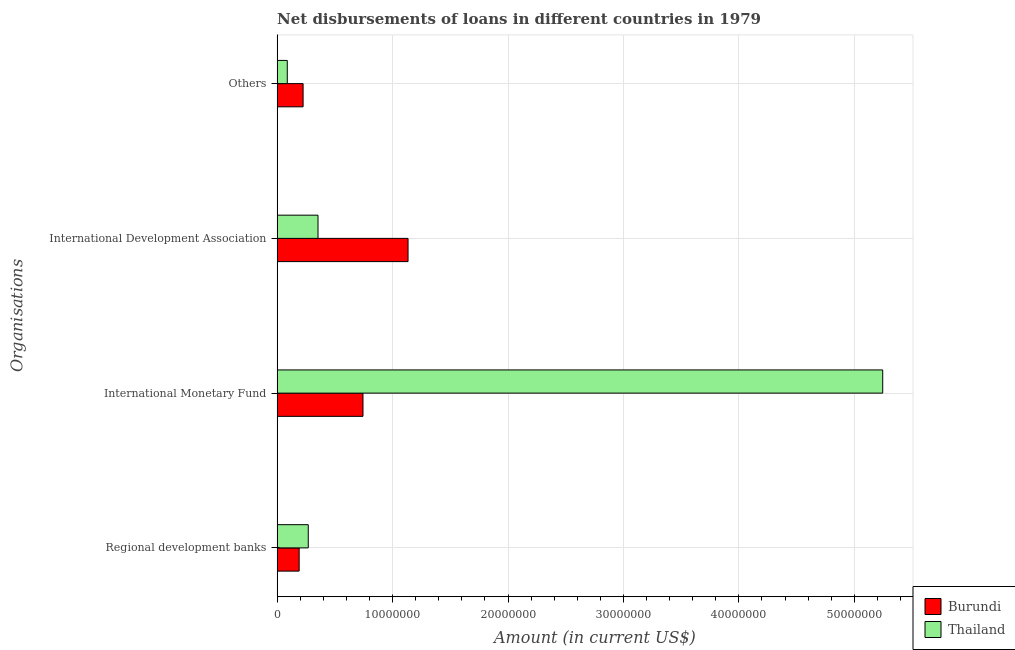How many different coloured bars are there?
Your answer should be very brief. 2. Are the number of bars per tick equal to the number of legend labels?
Offer a terse response. Yes. How many bars are there on the 4th tick from the top?
Ensure brevity in your answer.  2. How many bars are there on the 3rd tick from the bottom?
Keep it short and to the point. 2. What is the label of the 1st group of bars from the top?
Your answer should be compact. Others. What is the amount of loan disimbursed by international monetary fund in Burundi?
Your answer should be compact. 7.44e+06. Across all countries, what is the maximum amount of loan disimbursed by international development association?
Your response must be concise. 1.13e+07. Across all countries, what is the minimum amount of loan disimbursed by international monetary fund?
Make the answer very short. 7.44e+06. In which country was the amount of loan disimbursed by international monetary fund maximum?
Give a very brief answer. Thailand. In which country was the amount of loan disimbursed by international development association minimum?
Offer a terse response. Thailand. What is the total amount of loan disimbursed by international development association in the graph?
Provide a short and direct response. 1.49e+07. What is the difference between the amount of loan disimbursed by international development association in Burundi and that in Thailand?
Provide a succinct answer. 7.80e+06. What is the difference between the amount of loan disimbursed by international development association in Burundi and the amount of loan disimbursed by other organisations in Thailand?
Make the answer very short. 1.05e+07. What is the average amount of loan disimbursed by other organisations per country?
Keep it short and to the point. 1.56e+06. What is the difference between the amount of loan disimbursed by other organisations and amount of loan disimbursed by regional development banks in Burundi?
Provide a short and direct response. 3.42e+05. What is the ratio of the amount of loan disimbursed by international development association in Burundi to that in Thailand?
Provide a short and direct response. 3.2. Is the amount of loan disimbursed by international development association in Burundi less than that in Thailand?
Your answer should be very brief. No. What is the difference between the highest and the second highest amount of loan disimbursed by regional development banks?
Ensure brevity in your answer.  7.90e+05. What is the difference between the highest and the lowest amount of loan disimbursed by international development association?
Offer a terse response. 7.80e+06. In how many countries, is the amount of loan disimbursed by other organisations greater than the average amount of loan disimbursed by other organisations taken over all countries?
Provide a succinct answer. 1. Is the sum of the amount of loan disimbursed by international development association in Burundi and Thailand greater than the maximum amount of loan disimbursed by regional development banks across all countries?
Offer a very short reply. Yes. What does the 1st bar from the top in International Monetary Fund represents?
Ensure brevity in your answer.  Thailand. What does the 1st bar from the bottom in International Development Association represents?
Your response must be concise. Burundi. Are all the bars in the graph horizontal?
Your answer should be compact. Yes. What is the difference between two consecutive major ticks on the X-axis?
Offer a terse response. 1.00e+07. Are the values on the major ticks of X-axis written in scientific E-notation?
Provide a short and direct response. No. Does the graph contain any zero values?
Your answer should be very brief. No. Does the graph contain grids?
Provide a short and direct response. Yes. What is the title of the graph?
Offer a terse response. Net disbursements of loans in different countries in 1979. What is the label or title of the Y-axis?
Provide a short and direct response. Organisations. What is the Amount (in current US$) of Burundi in Regional development banks?
Your answer should be very brief. 1.91e+06. What is the Amount (in current US$) in Thailand in Regional development banks?
Your answer should be compact. 2.70e+06. What is the Amount (in current US$) in Burundi in International Monetary Fund?
Your response must be concise. 7.44e+06. What is the Amount (in current US$) of Thailand in International Monetary Fund?
Ensure brevity in your answer.  5.25e+07. What is the Amount (in current US$) of Burundi in International Development Association?
Provide a short and direct response. 1.13e+07. What is the Amount (in current US$) of Thailand in International Development Association?
Your response must be concise. 3.54e+06. What is the Amount (in current US$) in Burundi in Others?
Your answer should be compact. 2.25e+06. What is the Amount (in current US$) in Thailand in Others?
Offer a very short reply. 8.80e+05. Across all Organisations, what is the maximum Amount (in current US$) of Burundi?
Keep it short and to the point. 1.13e+07. Across all Organisations, what is the maximum Amount (in current US$) in Thailand?
Offer a very short reply. 5.25e+07. Across all Organisations, what is the minimum Amount (in current US$) in Burundi?
Provide a succinct answer. 1.91e+06. Across all Organisations, what is the minimum Amount (in current US$) in Thailand?
Your answer should be very brief. 8.80e+05. What is the total Amount (in current US$) in Burundi in the graph?
Provide a succinct answer. 2.29e+07. What is the total Amount (in current US$) of Thailand in the graph?
Offer a terse response. 5.96e+07. What is the difference between the Amount (in current US$) in Burundi in Regional development banks and that in International Monetary Fund?
Offer a very short reply. -5.53e+06. What is the difference between the Amount (in current US$) of Thailand in Regional development banks and that in International Monetary Fund?
Ensure brevity in your answer.  -4.98e+07. What is the difference between the Amount (in current US$) in Burundi in Regional development banks and that in International Development Association?
Give a very brief answer. -9.43e+06. What is the difference between the Amount (in current US$) of Thailand in Regional development banks and that in International Development Association?
Keep it short and to the point. -8.44e+05. What is the difference between the Amount (in current US$) in Burundi in Regional development banks and that in Others?
Your answer should be very brief. -3.42e+05. What is the difference between the Amount (in current US$) in Thailand in Regional development banks and that in Others?
Offer a very short reply. 1.82e+06. What is the difference between the Amount (in current US$) in Burundi in International Monetary Fund and that in International Development Association?
Give a very brief answer. -3.90e+06. What is the difference between the Amount (in current US$) of Thailand in International Monetary Fund and that in International Development Association?
Your answer should be very brief. 4.89e+07. What is the difference between the Amount (in current US$) in Burundi in International Monetary Fund and that in Others?
Offer a terse response. 5.19e+06. What is the difference between the Amount (in current US$) of Thailand in International Monetary Fund and that in Others?
Give a very brief answer. 5.16e+07. What is the difference between the Amount (in current US$) of Burundi in International Development Association and that in Others?
Make the answer very short. 9.09e+06. What is the difference between the Amount (in current US$) of Thailand in International Development Association and that in Others?
Ensure brevity in your answer.  2.66e+06. What is the difference between the Amount (in current US$) in Burundi in Regional development banks and the Amount (in current US$) in Thailand in International Monetary Fund?
Make the answer very short. -5.06e+07. What is the difference between the Amount (in current US$) in Burundi in Regional development banks and the Amount (in current US$) in Thailand in International Development Association?
Your response must be concise. -1.63e+06. What is the difference between the Amount (in current US$) in Burundi in Regional development banks and the Amount (in current US$) in Thailand in Others?
Make the answer very short. 1.03e+06. What is the difference between the Amount (in current US$) in Burundi in International Monetary Fund and the Amount (in current US$) in Thailand in International Development Association?
Your response must be concise. 3.90e+06. What is the difference between the Amount (in current US$) in Burundi in International Monetary Fund and the Amount (in current US$) in Thailand in Others?
Your response must be concise. 6.56e+06. What is the difference between the Amount (in current US$) of Burundi in International Development Association and the Amount (in current US$) of Thailand in Others?
Offer a terse response. 1.05e+07. What is the average Amount (in current US$) in Burundi per Organisations?
Your response must be concise. 5.73e+06. What is the average Amount (in current US$) of Thailand per Organisations?
Provide a succinct answer. 1.49e+07. What is the difference between the Amount (in current US$) in Burundi and Amount (in current US$) in Thailand in Regional development banks?
Provide a succinct answer. -7.90e+05. What is the difference between the Amount (in current US$) of Burundi and Amount (in current US$) of Thailand in International Monetary Fund?
Your answer should be very brief. -4.50e+07. What is the difference between the Amount (in current US$) of Burundi and Amount (in current US$) of Thailand in International Development Association?
Your response must be concise. 7.80e+06. What is the difference between the Amount (in current US$) in Burundi and Amount (in current US$) in Thailand in Others?
Offer a terse response. 1.37e+06. What is the ratio of the Amount (in current US$) of Burundi in Regional development banks to that in International Monetary Fund?
Offer a very short reply. 0.26. What is the ratio of the Amount (in current US$) of Thailand in Regional development banks to that in International Monetary Fund?
Your answer should be compact. 0.05. What is the ratio of the Amount (in current US$) in Burundi in Regional development banks to that in International Development Association?
Keep it short and to the point. 0.17. What is the ratio of the Amount (in current US$) of Thailand in Regional development banks to that in International Development Association?
Keep it short and to the point. 0.76. What is the ratio of the Amount (in current US$) in Burundi in Regional development banks to that in Others?
Your answer should be very brief. 0.85. What is the ratio of the Amount (in current US$) of Thailand in Regional development banks to that in Others?
Ensure brevity in your answer.  3.07. What is the ratio of the Amount (in current US$) of Burundi in International Monetary Fund to that in International Development Association?
Provide a succinct answer. 0.66. What is the ratio of the Amount (in current US$) of Thailand in International Monetary Fund to that in International Development Association?
Offer a terse response. 14.81. What is the ratio of the Amount (in current US$) of Burundi in International Monetary Fund to that in Others?
Provide a short and direct response. 3.31. What is the ratio of the Amount (in current US$) in Thailand in International Monetary Fund to that in Others?
Provide a short and direct response. 59.61. What is the ratio of the Amount (in current US$) of Burundi in International Development Association to that in Others?
Ensure brevity in your answer.  5.04. What is the ratio of the Amount (in current US$) of Thailand in International Development Association to that in Others?
Provide a succinct answer. 4.03. What is the difference between the highest and the second highest Amount (in current US$) in Burundi?
Provide a succinct answer. 3.90e+06. What is the difference between the highest and the second highest Amount (in current US$) of Thailand?
Your response must be concise. 4.89e+07. What is the difference between the highest and the lowest Amount (in current US$) in Burundi?
Give a very brief answer. 9.43e+06. What is the difference between the highest and the lowest Amount (in current US$) of Thailand?
Ensure brevity in your answer.  5.16e+07. 